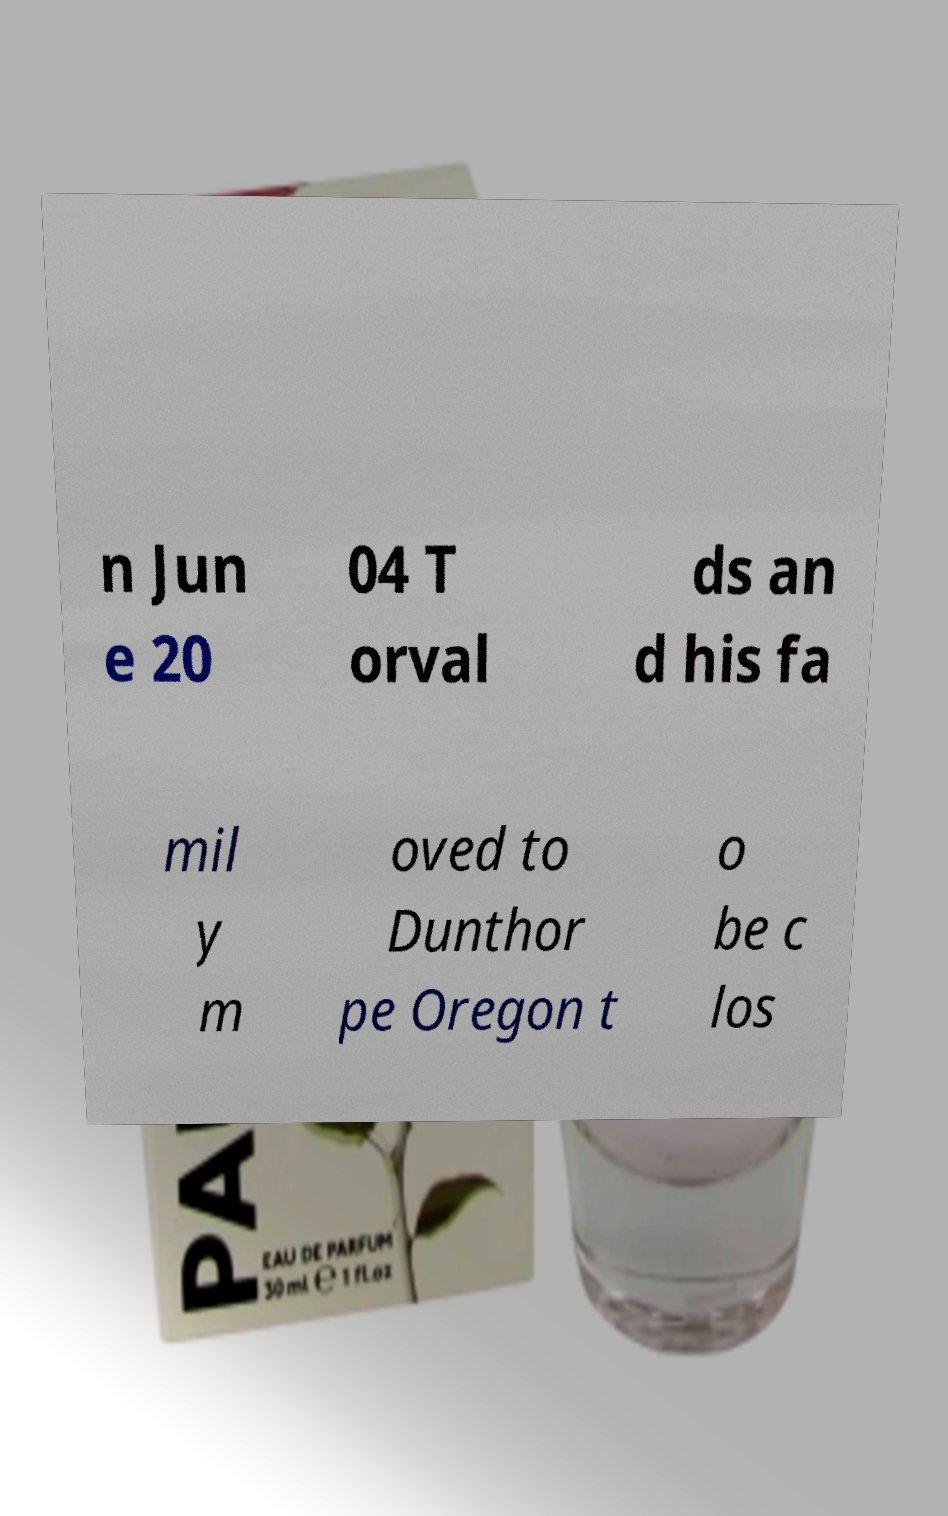For documentation purposes, I need the text within this image transcribed. Could you provide that? n Jun e 20 04 T orval ds an d his fa mil y m oved to Dunthor pe Oregon t o be c los 